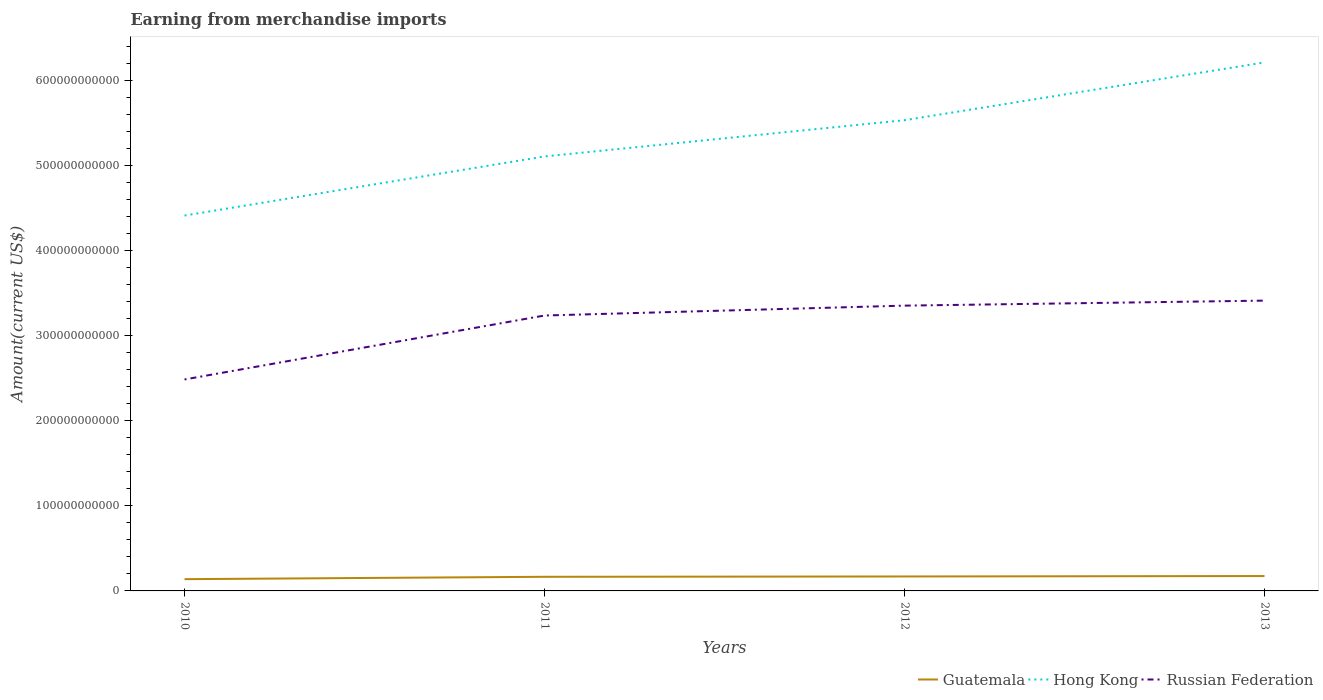How many different coloured lines are there?
Give a very brief answer. 3. Across all years, what is the maximum amount earned from merchandise imports in Guatemala?
Provide a short and direct response. 1.38e+1. In which year was the amount earned from merchandise imports in Russian Federation maximum?
Give a very brief answer. 2010. What is the total amount earned from merchandise imports in Guatemala in the graph?
Offer a terse response. -3.68e+09. What is the difference between the highest and the second highest amount earned from merchandise imports in Hong Kong?
Keep it short and to the point. 1.80e+11. What is the difference between the highest and the lowest amount earned from merchandise imports in Guatemala?
Keep it short and to the point. 3. Is the amount earned from merchandise imports in Hong Kong strictly greater than the amount earned from merchandise imports in Guatemala over the years?
Your answer should be very brief. No. What is the difference between two consecutive major ticks on the Y-axis?
Keep it short and to the point. 1.00e+11. Are the values on the major ticks of Y-axis written in scientific E-notation?
Your answer should be very brief. No. Does the graph contain any zero values?
Offer a very short reply. No. Does the graph contain grids?
Offer a very short reply. No. Where does the legend appear in the graph?
Your response must be concise. Bottom right. How many legend labels are there?
Ensure brevity in your answer.  3. How are the legend labels stacked?
Keep it short and to the point. Horizontal. What is the title of the graph?
Make the answer very short. Earning from merchandise imports. Does "Rwanda" appear as one of the legend labels in the graph?
Offer a terse response. No. What is the label or title of the X-axis?
Make the answer very short. Years. What is the label or title of the Y-axis?
Ensure brevity in your answer.  Amount(current US$). What is the Amount(current US$) in Guatemala in 2010?
Provide a succinct answer. 1.38e+1. What is the Amount(current US$) in Hong Kong in 2010?
Offer a very short reply. 4.41e+11. What is the Amount(current US$) of Russian Federation in 2010?
Your answer should be compact. 2.49e+11. What is the Amount(current US$) of Guatemala in 2011?
Keep it short and to the point. 1.66e+1. What is the Amount(current US$) in Hong Kong in 2011?
Give a very brief answer. 5.11e+11. What is the Amount(current US$) in Russian Federation in 2011?
Offer a very short reply. 3.24e+11. What is the Amount(current US$) in Guatemala in 2012?
Ensure brevity in your answer.  1.70e+1. What is the Amount(current US$) of Hong Kong in 2012?
Make the answer very short. 5.53e+11. What is the Amount(current US$) in Russian Federation in 2012?
Offer a terse response. 3.35e+11. What is the Amount(current US$) of Guatemala in 2013?
Offer a terse response. 1.75e+1. What is the Amount(current US$) of Hong Kong in 2013?
Your answer should be very brief. 6.21e+11. What is the Amount(current US$) of Russian Federation in 2013?
Ensure brevity in your answer.  3.41e+11. Across all years, what is the maximum Amount(current US$) in Guatemala?
Provide a short and direct response. 1.75e+1. Across all years, what is the maximum Amount(current US$) of Hong Kong?
Ensure brevity in your answer.  6.21e+11. Across all years, what is the maximum Amount(current US$) in Russian Federation?
Offer a very short reply. 3.41e+11. Across all years, what is the minimum Amount(current US$) of Guatemala?
Give a very brief answer. 1.38e+1. Across all years, what is the minimum Amount(current US$) of Hong Kong?
Ensure brevity in your answer.  4.41e+11. Across all years, what is the minimum Amount(current US$) of Russian Federation?
Provide a succinct answer. 2.49e+11. What is the total Amount(current US$) in Guatemala in the graph?
Give a very brief answer. 6.50e+1. What is the total Amount(current US$) of Hong Kong in the graph?
Ensure brevity in your answer.  2.13e+12. What is the total Amount(current US$) in Russian Federation in the graph?
Your response must be concise. 1.25e+12. What is the difference between the Amount(current US$) in Guatemala in 2010 and that in 2011?
Your response must be concise. -2.77e+09. What is the difference between the Amount(current US$) of Hong Kong in 2010 and that in 2011?
Offer a very short reply. -6.95e+1. What is the difference between the Amount(current US$) of Russian Federation in 2010 and that in 2011?
Ensure brevity in your answer.  -7.52e+1. What is the difference between the Amount(current US$) of Guatemala in 2010 and that in 2012?
Provide a short and direct response. -3.16e+09. What is the difference between the Amount(current US$) of Hong Kong in 2010 and that in 2012?
Make the answer very short. -1.12e+11. What is the difference between the Amount(current US$) of Russian Federation in 2010 and that in 2012?
Provide a short and direct response. -8.68e+1. What is the difference between the Amount(current US$) in Guatemala in 2010 and that in 2013?
Offer a terse response. -3.68e+09. What is the difference between the Amount(current US$) in Hong Kong in 2010 and that in 2013?
Your response must be concise. -1.80e+11. What is the difference between the Amount(current US$) of Russian Federation in 2010 and that in 2013?
Keep it short and to the point. -9.27e+1. What is the difference between the Amount(current US$) in Guatemala in 2011 and that in 2012?
Offer a terse response. -3.81e+08. What is the difference between the Amount(current US$) in Hong Kong in 2011 and that in 2012?
Offer a terse response. -4.26e+1. What is the difference between the Amount(current US$) of Russian Federation in 2011 and that in 2012?
Ensure brevity in your answer.  -1.16e+1. What is the difference between the Amount(current US$) in Guatemala in 2011 and that in 2013?
Offer a very short reply. -9.02e+08. What is the difference between the Amount(current US$) in Hong Kong in 2011 and that in 2013?
Keep it short and to the point. -1.11e+11. What is the difference between the Amount(current US$) of Russian Federation in 2011 and that in 2013?
Your answer should be compact. -1.75e+1. What is the difference between the Amount(current US$) in Guatemala in 2012 and that in 2013?
Make the answer very short. -5.21e+08. What is the difference between the Amount(current US$) of Hong Kong in 2012 and that in 2013?
Your answer should be compact. -6.79e+1. What is the difference between the Amount(current US$) of Russian Federation in 2012 and that in 2013?
Give a very brief answer. -5.89e+09. What is the difference between the Amount(current US$) of Guatemala in 2010 and the Amount(current US$) of Hong Kong in 2011?
Keep it short and to the point. -4.97e+11. What is the difference between the Amount(current US$) in Guatemala in 2010 and the Amount(current US$) in Russian Federation in 2011?
Provide a succinct answer. -3.10e+11. What is the difference between the Amount(current US$) in Hong Kong in 2010 and the Amount(current US$) in Russian Federation in 2011?
Offer a very short reply. 1.18e+11. What is the difference between the Amount(current US$) of Guatemala in 2010 and the Amount(current US$) of Hong Kong in 2012?
Offer a very short reply. -5.40e+11. What is the difference between the Amount(current US$) in Guatemala in 2010 and the Amount(current US$) in Russian Federation in 2012?
Provide a short and direct response. -3.22e+11. What is the difference between the Amount(current US$) in Hong Kong in 2010 and the Amount(current US$) in Russian Federation in 2012?
Provide a succinct answer. 1.06e+11. What is the difference between the Amount(current US$) of Guatemala in 2010 and the Amount(current US$) of Hong Kong in 2013?
Give a very brief answer. -6.08e+11. What is the difference between the Amount(current US$) in Guatemala in 2010 and the Amount(current US$) in Russian Federation in 2013?
Your answer should be compact. -3.27e+11. What is the difference between the Amount(current US$) in Hong Kong in 2010 and the Amount(current US$) in Russian Federation in 2013?
Your response must be concise. 1.00e+11. What is the difference between the Amount(current US$) of Guatemala in 2011 and the Amount(current US$) of Hong Kong in 2012?
Make the answer very short. -5.37e+11. What is the difference between the Amount(current US$) in Guatemala in 2011 and the Amount(current US$) in Russian Federation in 2012?
Your answer should be compact. -3.19e+11. What is the difference between the Amount(current US$) of Hong Kong in 2011 and the Amount(current US$) of Russian Federation in 2012?
Make the answer very short. 1.75e+11. What is the difference between the Amount(current US$) of Guatemala in 2011 and the Amount(current US$) of Hong Kong in 2013?
Ensure brevity in your answer.  -6.05e+11. What is the difference between the Amount(current US$) of Guatemala in 2011 and the Amount(current US$) of Russian Federation in 2013?
Your answer should be compact. -3.25e+11. What is the difference between the Amount(current US$) of Hong Kong in 2011 and the Amount(current US$) of Russian Federation in 2013?
Offer a terse response. 1.70e+11. What is the difference between the Amount(current US$) of Guatemala in 2012 and the Amount(current US$) of Hong Kong in 2013?
Your answer should be very brief. -6.04e+11. What is the difference between the Amount(current US$) of Guatemala in 2012 and the Amount(current US$) of Russian Federation in 2013?
Offer a very short reply. -3.24e+11. What is the difference between the Amount(current US$) in Hong Kong in 2012 and the Amount(current US$) in Russian Federation in 2013?
Provide a succinct answer. 2.12e+11. What is the average Amount(current US$) of Guatemala per year?
Make the answer very short. 1.62e+1. What is the average Amount(current US$) in Hong Kong per year?
Offer a terse response. 5.32e+11. What is the average Amount(current US$) in Russian Federation per year?
Your answer should be compact. 3.12e+11. In the year 2010, what is the difference between the Amount(current US$) of Guatemala and Amount(current US$) of Hong Kong?
Provide a short and direct response. -4.28e+11. In the year 2010, what is the difference between the Amount(current US$) in Guatemala and Amount(current US$) in Russian Federation?
Make the answer very short. -2.35e+11. In the year 2010, what is the difference between the Amount(current US$) in Hong Kong and Amount(current US$) in Russian Federation?
Your answer should be compact. 1.93e+11. In the year 2011, what is the difference between the Amount(current US$) in Guatemala and Amount(current US$) in Hong Kong?
Offer a very short reply. -4.94e+11. In the year 2011, what is the difference between the Amount(current US$) in Guatemala and Amount(current US$) in Russian Federation?
Your response must be concise. -3.07e+11. In the year 2011, what is the difference between the Amount(current US$) in Hong Kong and Amount(current US$) in Russian Federation?
Make the answer very short. 1.87e+11. In the year 2012, what is the difference between the Amount(current US$) of Guatemala and Amount(current US$) of Hong Kong?
Your answer should be compact. -5.36e+11. In the year 2012, what is the difference between the Amount(current US$) in Guatemala and Amount(current US$) in Russian Federation?
Keep it short and to the point. -3.18e+11. In the year 2012, what is the difference between the Amount(current US$) of Hong Kong and Amount(current US$) of Russian Federation?
Make the answer very short. 2.18e+11. In the year 2013, what is the difference between the Amount(current US$) of Guatemala and Amount(current US$) of Hong Kong?
Offer a very short reply. -6.04e+11. In the year 2013, what is the difference between the Amount(current US$) of Guatemala and Amount(current US$) of Russian Federation?
Keep it short and to the point. -3.24e+11. In the year 2013, what is the difference between the Amount(current US$) of Hong Kong and Amount(current US$) of Russian Federation?
Give a very brief answer. 2.80e+11. What is the ratio of the Amount(current US$) in Guatemala in 2010 to that in 2011?
Ensure brevity in your answer.  0.83. What is the ratio of the Amount(current US$) of Hong Kong in 2010 to that in 2011?
Your answer should be very brief. 0.86. What is the ratio of the Amount(current US$) of Russian Federation in 2010 to that in 2011?
Ensure brevity in your answer.  0.77. What is the ratio of the Amount(current US$) in Guatemala in 2010 to that in 2012?
Your answer should be very brief. 0.81. What is the ratio of the Amount(current US$) in Hong Kong in 2010 to that in 2012?
Your response must be concise. 0.8. What is the ratio of the Amount(current US$) in Russian Federation in 2010 to that in 2012?
Offer a very short reply. 0.74. What is the ratio of the Amount(current US$) in Guatemala in 2010 to that in 2013?
Provide a short and direct response. 0.79. What is the ratio of the Amount(current US$) in Hong Kong in 2010 to that in 2013?
Your answer should be very brief. 0.71. What is the ratio of the Amount(current US$) in Russian Federation in 2010 to that in 2013?
Your response must be concise. 0.73. What is the ratio of the Amount(current US$) of Guatemala in 2011 to that in 2012?
Your answer should be compact. 0.98. What is the ratio of the Amount(current US$) of Hong Kong in 2011 to that in 2012?
Make the answer very short. 0.92. What is the ratio of the Amount(current US$) of Russian Federation in 2011 to that in 2012?
Make the answer very short. 0.97. What is the ratio of the Amount(current US$) of Guatemala in 2011 to that in 2013?
Make the answer very short. 0.95. What is the ratio of the Amount(current US$) in Hong Kong in 2011 to that in 2013?
Make the answer very short. 0.82. What is the ratio of the Amount(current US$) in Russian Federation in 2011 to that in 2013?
Offer a very short reply. 0.95. What is the ratio of the Amount(current US$) in Guatemala in 2012 to that in 2013?
Your answer should be very brief. 0.97. What is the ratio of the Amount(current US$) of Hong Kong in 2012 to that in 2013?
Give a very brief answer. 0.89. What is the ratio of the Amount(current US$) of Russian Federation in 2012 to that in 2013?
Offer a very short reply. 0.98. What is the difference between the highest and the second highest Amount(current US$) of Guatemala?
Make the answer very short. 5.21e+08. What is the difference between the highest and the second highest Amount(current US$) in Hong Kong?
Provide a short and direct response. 6.79e+1. What is the difference between the highest and the second highest Amount(current US$) of Russian Federation?
Ensure brevity in your answer.  5.89e+09. What is the difference between the highest and the lowest Amount(current US$) in Guatemala?
Your answer should be compact. 3.68e+09. What is the difference between the highest and the lowest Amount(current US$) in Hong Kong?
Keep it short and to the point. 1.80e+11. What is the difference between the highest and the lowest Amount(current US$) in Russian Federation?
Provide a succinct answer. 9.27e+1. 